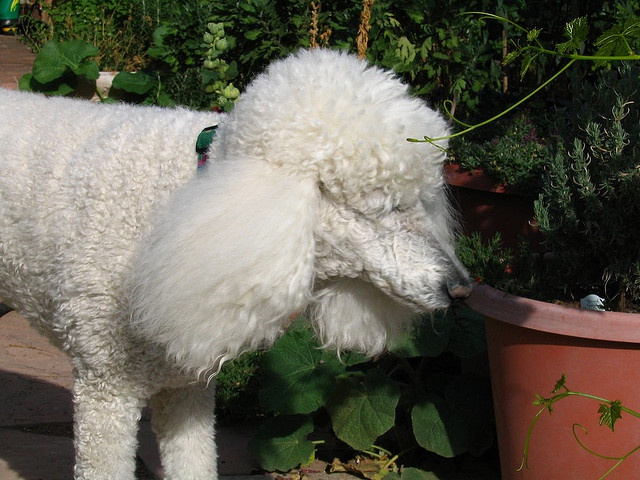Describe the objects in this image and their specific colors. I can see dog in darkgreen, lightgray, darkgray, and gray tones, potted plant in darkgreen, black, brown, and maroon tones, and potted plant in darkgreen, black, and gray tones in this image. 